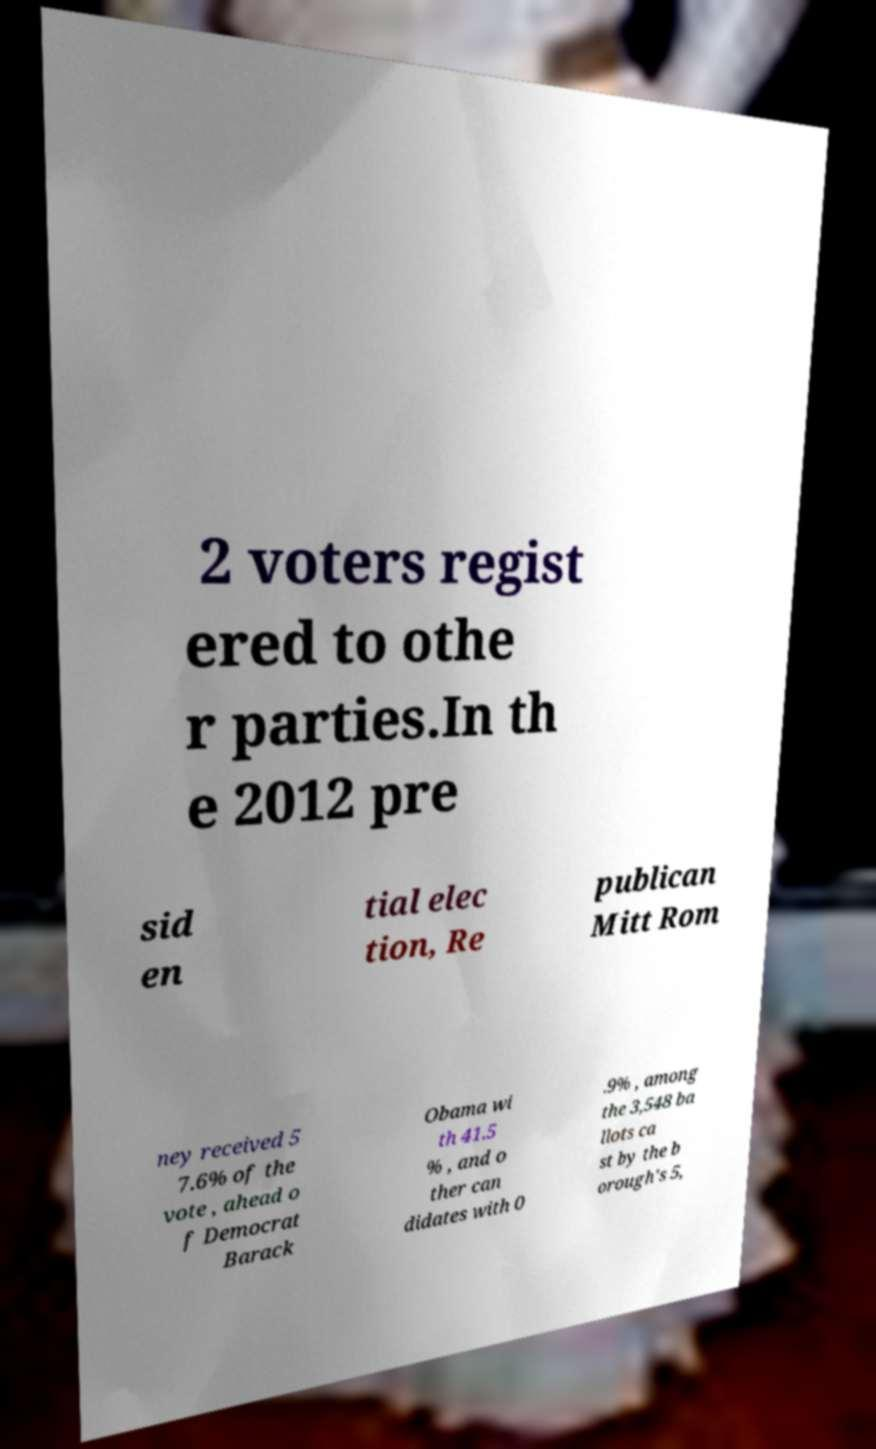What messages or text are displayed in this image? I need them in a readable, typed format. 2 voters regist ered to othe r parties.In th e 2012 pre sid en tial elec tion, Re publican Mitt Rom ney received 5 7.6% of the vote , ahead o f Democrat Barack Obama wi th 41.5 % , and o ther can didates with 0 .9% , among the 3,548 ba llots ca st by the b orough's 5, 